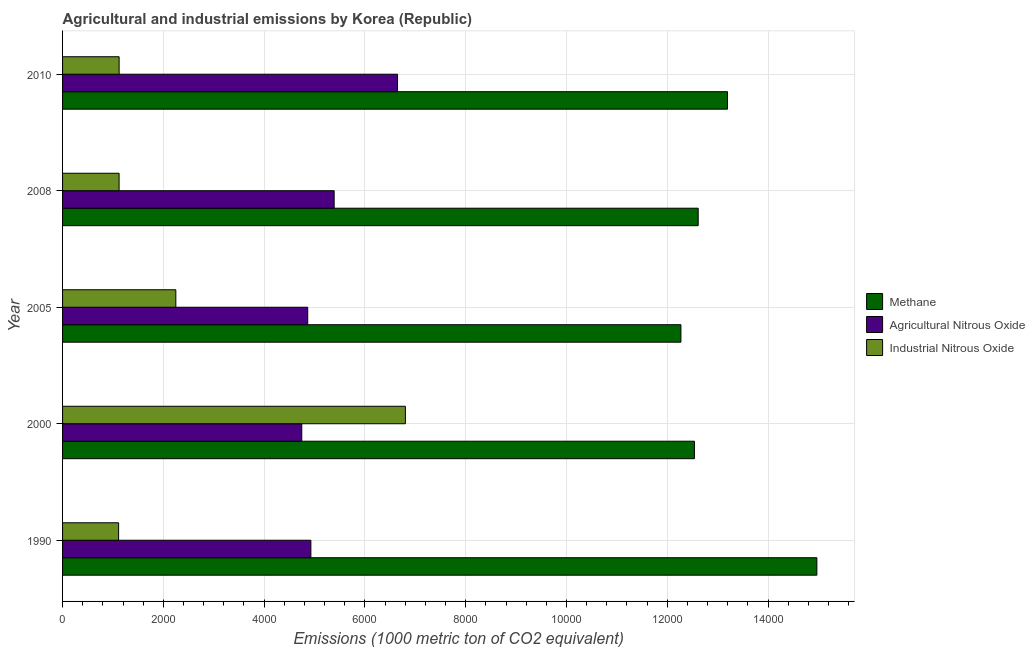How many groups of bars are there?
Provide a short and direct response. 5. Are the number of bars on each tick of the Y-axis equal?
Your answer should be compact. Yes. How many bars are there on the 4th tick from the top?
Offer a very short reply. 3. What is the label of the 5th group of bars from the top?
Offer a terse response. 1990. In how many cases, is the number of bars for a given year not equal to the number of legend labels?
Offer a terse response. 0. What is the amount of methane emissions in 2008?
Your response must be concise. 1.26e+04. Across all years, what is the maximum amount of industrial nitrous oxide emissions?
Keep it short and to the point. 6803. Across all years, what is the minimum amount of agricultural nitrous oxide emissions?
Your answer should be compact. 4746.8. What is the total amount of industrial nitrous oxide emissions in the graph?
Offer a very short reply. 1.24e+04. What is the difference between the amount of methane emissions in 2000 and that in 2008?
Make the answer very short. -74.3. What is the difference between the amount of methane emissions in 2000 and the amount of agricultural nitrous oxide emissions in 2010?
Provide a succinct answer. 5891.8. What is the average amount of agricultural nitrous oxide emissions per year?
Make the answer very short. 5315.22. In the year 1990, what is the difference between the amount of industrial nitrous oxide emissions and amount of agricultural nitrous oxide emissions?
Offer a terse response. -3815.1. In how many years, is the amount of industrial nitrous oxide emissions greater than 11200 metric ton?
Provide a short and direct response. 0. What is the ratio of the amount of agricultural nitrous oxide emissions in 1990 to that in 2005?
Your response must be concise. 1.01. Is the amount of methane emissions in 1990 less than that in 2010?
Your answer should be compact. No. Is the difference between the amount of industrial nitrous oxide emissions in 2000 and 2008 greater than the difference between the amount of agricultural nitrous oxide emissions in 2000 and 2008?
Your response must be concise. Yes. What is the difference between the highest and the second highest amount of methane emissions?
Your answer should be compact. 1774. What is the difference between the highest and the lowest amount of industrial nitrous oxide emissions?
Give a very brief answer. 5690.7. In how many years, is the amount of industrial nitrous oxide emissions greater than the average amount of industrial nitrous oxide emissions taken over all years?
Your response must be concise. 1. Is the sum of the amount of methane emissions in 1990 and 2008 greater than the maximum amount of agricultural nitrous oxide emissions across all years?
Ensure brevity in your answer.  Yes. What does the 1st bar from the top in 1990 represents?
Your response must be concise. Industrial Nitrous Oxide. What does the 2nd bar from the bottom in 2000 represents?
Your response must be concise. Agricultural Nitrous Oxide. How many bars are there?
Provide a succinct answer. 15. Are all the bars in the graph horizontal?
Make the answer very short. Yes. How many years are there in the graph?
Your answer should be compact. 5. Are the values on the major ticks of X-axis written in scientific E-notation?
Your answer should be compact. No. Does the graph contain any zero values?
Give a very brief answer. No. How many legend labels are there?
Offer a very short reply. 3. How are the legend labels stacked?
Provide a short and direct response. Vertical. What is the title of the graph?
Your response must be concise. Agricultural and industrial emissions by Korea (Republic). Does "Agricultural raw materials" appear as one of the legend labels in the graph?
Provide a short and direct response. No. What is the label or title of the X-axis?
Give a very brief answer. Emissions (1000 metric ton of CO2 equivalent). What is the Emissions (1000 metric ton of CO2 equivalent) of Methane in 1990?
Your response must be concise. 1.50e+04. What is the Emissions (1000 metric ton of CO2 equivalent) of Agricultural Nitrous Oxide in 1990?
Ensure brevity in your answer.  4927.4. What is the Emissions (1000 metric ton of CO2 equivalent) of Industrial Nitrous Oxide in 1990?
Ensure brevity in your answer.  1112.3. What is the Emissions (1000 metric ton of CO2 equivalent) in Methane in 2000?
Ensure brevity in your answer.  1.25e+04. What is the Emissions (1000 metric ton of CO2 equivalent) of Agricultural Nitrous Oxide in 2000?
Keep it short and to the point. 4746.8. What is the Emissions (1000 metric ton of CO2 equivalent) in Industrial Nitrous Oxide in 2000?
Make the answer very short. 6803. What is the Emissions (1000 metric ton of CO2 equivalent) of Methane in 2005?
Keep it short and to the point. 1.23e+04. What is the Emissions (1000 metric ton of CO2 equivalent) of Agricultural Nitrous Oxide in 2005?
Provide a succinct answer. 4865. What is the Emissions (1000 metric ton of CO2 equivalent) in Industrial Nitrous Oxide in 2005?
Your answer should be compact. 2247.5. What is the Emissions (1000 metric ton of CO2 equivalent) of Methane in 2008?
Provide a succinct answer. 1.26e+04. What is the Emissions (1000 metric ton of CO2 equivalent) in Agricultural Nitrous Oxide in 2008?
Provide a short and direct response. 5389.6. What is the Emissions (1000 metric ton of CO2 equivalent) in Industrial Nitrous Oxide in 2008?
Ensure brevity in your answer.  1121.9. What is the Emissions (1000 metric ton of CO2 equivalent) of Methane in 2010?
Make the answer very short. 1.32e+04. What is the Emissions (1000 metric ton of CO2 equivalent) in Agricultural Nitrous Oxide in 2010?
Offer a terse response. 6647.3. What is the Emissions (1000 metric ton of CO2 equivalent) in Industrial Nitrous Oxide in 2010?
Offer a terse response. 1122.5. Across all years, what is the maximum Emissions (1000 metric ton of CO2 equivalent) of Methane?
Your response must be concise. 1.50e+04. Across all years, what is the maximum Emissions (1000 metric ton of CO2 equivalent) of Agricultural Nitrous Oxide?
Keep it short and to the point. 6647.3. Across all years, what is the maximum Emissions (1000 metric ton of CO2 equivalent) of Industrial Nitrous Oxide?
Ensure brevity in your answer.  6803. Across all years, what is the minimum Emissions (1000 metric ton of CO2 equivalent) in Methane?
Your answer should be very brief. 1.23e+04. Across all years, what is the minimum Emissions (1000 metric ton of CO2 equivalent) in Agricultural Nitrous Oxide?
Provide a short and direct response. 4746.8. Across all years, what is the minimum Emissions (1000 metric ton of CO2 equivalent) of Industrial Nitrous Oxide?
Your answer should be compact. 1112.3. What is the total Emissions (1000 metric ton of CO2 equivalent) of Methane in the graph?
Give a very brief answer. 6.56e+04. What is the total Emissions (1000 metric ton of CO2 equivalent) of Agricultural Nitrous Oxide in the graph?
Your answer should be compact. 2.66e+04. What is the total Emissions (1000 metric ton of CO2 equivalent) of Industrial Nitrous Oxide in the graph?
Your response must be concise. 1.24e+04. What is the difference between the Emissions (1000 metric ton of CO2 equivalent) in Methane in 1990 and that in 2000?
Your answer should be compact. 2429.6. What is the difference between the Emissions (1000 metric ton of CO2 equivalent) of Agricultural Nitrous Oxide in 1990 and that in 2000?
Offer a terse response. 180.6. What is the difference between the Emissions (1000 metric ton of CO2 equivalent) of Industrial Nitrous Oxide in 1990 and that in 2000?
Keep it short and to the point. -5690.7. What is the difference between the Emissions (1000 metric ton of CO2 equivalent) of Methane in 1990 and that in 2005?
Your answer should be compact. 2697.7. What is the difference between the Emissions (1000 metric ton of CO2 equivalent) in Agricultural Nitrous Oxide in 1990 and that in 2005?
Make the answer very short. 62.4. What is the difference between the Emissions (1000 metric ton of CO2 equivalent) in Industrial Nitrous Oxide in 1990 and that in 2005?
Make the answer very short. -1135.2. What is the difference between the Emissions (1000 metric ton of CO2 equivalent) of Methane in 1990 and that in 2008?
Make the answer very short. 2355.3. What is the difference between the Emissions (1000 metric ton of CO2 equivalent) in Agricultural Nitrous Oxide in 1990 and that in 2008?
Provide a short and direct response. -462.2. What is the difference between the Emissions (1000 metric ton of CO2 equivalent) of Methane in 1990 and that in 2010?
Ensure brevity in your answer.  1774. What is the difference between the Emissions (1000 metric ton of CO2 equivalent) in Agricultural Nitrous Oxide in 1990 and that in 2010?
Provide a short and direct response. -1719.9. What is the difference between the Emissions (1000 metric ton of CO2 equivalent) in Industrial Nitrous Oxide in 1990 and that in 2010?
Your answer should be very brief. -10.2. What is the difference between the Emissions (1000 metric ton of CO2 equivalent) of Methane in 2000 and that in 2005?
Provide a succinct answer. 268.1. What is the difference between the Emissions (1000 metric ton of CO2 equivalent) of Agricultural Nitrous Oxide in 2000 and that in 2005?
Offer a terse response. -118.2. What is the difference between the Emissions (1000 metric ton of CO2 equivalent) in Industrial Nitrous Oxide in 2000 and that in 2005?
Offer a terse response. 4555.5. What is the difference between the Emissions (1000 metric ton of CO2 equivalent) of Methane in 2000 and that in 2008?
Keep it short and to the point. -74.3. What is the difference between the Emissions (1000 metric ton of CO2 equivalent) in Agricultural Nitrous Oxide in 2000 and that in 2008?
Make the answer very short. -642.8. What is the difference between the Emissions (1000 metric ton of CO2 equivalent) in Industrial Nitrous Oxide in 2000 and that in 2008?
Your answer should be compact. 5681.1. What is the difference between the Emissions (1000 metric ton of CO2 equivalent) of Methane in 2000 and that in 2010?
Offer a terse response. -655.6. What is the difference between the Emissions (1000 metric ton of CO2 equivalent) in Agricultural Nitrous Oxide in 2000 and that in 2010?
Make the answer very short. -1900.5. What is the difference between the Emissions (1000 metric ton of CO2 equivalent) of Industrial Nitrous Oxide in 2000 and that in 2010?
Your response must be concise. 5680.5. What is the difference between the Emissions (1000 metric ton of CO2 equivalent) in Methane in 2005 and that in 2008?
Offer a very short reply. -342.4. What is the difference between the Emissions (1000 metric ton of CO2 equivalent) of Agricultural Nitrous Oxide in 2005 and that in 2008?
Offer a very short reply. -524.6. What is the difference between the Emissions (1000 metric ton of CO2 equivalent) of Industrial Nitrous Oxide in 2005 and that in 2008?
Ensure brevity in your answer.  1125.6. What is the difference between the Emissions (1000 metric ton of CO2 equivalent) of Methane in 2005 and that in 2010?
Give a very brief answer. -923.7. What is the difference between the Emissions (1000 metric ton of CO2 equivalent) in Agricultural Nitrous Oxide in 2005 and that in 2010?
Your answer should be very brief. -1782.3. What is the difference between the Emissions (1000 metric ton of CO2 equivalent) in Industrial Nitrous Oxide in 2005 and that in 2010?
Your answer should be very brief. 1125. What is the difference between the Emissions (1000 metric ton of CO2 equivalent) of Methane in 2008 and that in 2010?
Provide a succinct answer. -581.3. What is the difference between the Emissions (1000 metric ton of CO2 equivalent) in Agricultural Nitrous Oxide in 2008 and that in 2010?
Your answer should be very brief. -1257.7. What is the difference between the Emissions (1000 metric ton of CO2 equivalent) in Methane in 1990 and the Emissions (1000 metric ton of CO2 equivalent) in Agricultural Nitrous Oxide in 2000?
Make the answer very short. 1.02e+04. What is the difference between the Emissions (1000 metric ton of CO2 equivalent) in Methane in 1990 and the Emissions (1000 metric ton of CO2 equivalent) in Industrial Nitrous Oxide in 2000?
Offer a very short reply. 8165.7. What is the difference between the Emissions (1000 metric ton of CO2 equivalent) of Agricultural Nitrous Oxide in 1990 and the Emissions (1000 metric ton of CO2 equivalent) of Industrial Nitrous Oxide in 2000?
Ensure brevity in your answer.  -1875.6. What is the difference between the Emissions (1000 metric ton of CO2 equivalent) of Methane in 1990 and the Emissions (1000 metric ton of CO2 equivalent) of Agricultural Nitrous Oxide in 2005?
Make the answer very short. 1.01e+04. What is the difference between the Emissions (1000 metric ton of CO2 equivalent) of Methane in 1990 and the Emissions (1000 metric ton of CO2 equivalent) of Industrial Nitrous Oxide in 2005?
Offer a terse response. 1.27e+04. What is the difference between the Emissions (1000 metric ton of CO2 equivalent) in Agricultural Nitrous Oxide in 1990 and the Emissions (1000 metric ton of CO2 equivalent) in Industrial Nitrous Oxide in 2005?
Offer a terse response. 2679.9. What is the difference between the Emissions (1000 metric ton of CO2 equivalent) in Methane in 1990 and the Emissions (1000 metric ton of CO2 equivalent) in Agricultural Nitrous Oxide in 2008?
Your response must be concise. 9579.1. What is the difference between the Emissions (1000 metric ton of CO2 equivalent) of Methane in 1990 and the Emissions (1000 metric ton of CO2 equivalent) of Industrial Nitrous Oxide in 2008?
Offer a very short reply. 1.38e+04. What is the difference between the Emissions (1000 metric ton of CO2 equivalent) of Agricultural Nitrous Oxide in 1990 and the Emissions (1000 metric ton of CO2 equivalent) of Industrial Nitrous Oxide in 2008?
Your answer should be very brief. 3805.5. What is the difference between the Emissions (1000 metric ton of CO2 equivalent) in Methane in 1990 and the Emissions (1000 metric ton of CO2 equivalent) in Agricultural Nitrous Oxide in 2010?
Your answer should be compact. 8321.4. What is the difference between the Emissions (1000 metric ton of CO2 equivalent) in Methane in 1990 and the Emissions (1000 metric ton of CO2 equivalent) in Industrial Nitrous Oxide in 2010?
Offer a terse response. 1.38e+04. What is the difference between the Emissions (1000 metric ton of CO2 equivalent) in Agricultural Nitrous Oxide in 1990 and the Emissions (1000 metric ton of CO2 equivalent) in Industrial Nitrous Oxide in 2010?
Ensure brevity in your answer.  3804.9. What is the difference between the Emissions (1000 metric ton of CO2 equivalent) in Methane in 2000 and the Emissions (1000 metric ton of CO2 equivalent) in Agricultural Nitrous Oxide in 2005?
Provide a succinct answer. 7674.1. What is the difference between the Emissions (1000 metric ton of CO2 equivalent) in Methane in 2000 and the Emissions (1000 metric ton of CO2 equivalent) in Industrial Nitrous Oxide in 2005?
Make the answer very short. 1.03e+04. What is the difference between the Emissions (1000 metric ton of CO2 equivalent) in Agricultural Nitrous Oxide in 2000 and the Emissions (1000 metric ton of CO2 equivalent) in Industrial Nitrous Oxide in 2005?
Make the answer very short. 2499.3. What is the difference between the Emissions (1000 metric ton of CO2 equivalent) of Methane in 2000 and the Emissions (1000 metric ton of CO2 equivalent) of Agricultural Nitrous Oxide in 2008?
Make the answer very short. 7149.5. What is the difference between the Emissions (1000 metric ton of CO2 equivalent) of Methane in 2000 and the Emissions (1000 metric ton of CO2 equivalent) of Industrial Nitrous Oxide in 2008?
Offer a terse response. 1.14e+04. What is the difference between the Emissions (1000 metric ton of CO2 equivalent) in Agricultural Nitrous Oxide in 2000 and the Emissions (1000 metric ton of CO2 equivalent) in Industrial Nitrous Oxide in 2008?
Keep it short and to the point. 3624.9. What is the difference between the Emissions (1000 metric ton of CO2 equivalent) in Methane in 2000 and the Emissions (1000 metric ton of CO2 equivalent) in Agricultural Nitrous Oxide in 2010?
Your response must be concise. 5891.8. What is the difference between the Emissions (1000 metric ton of CO2 equivalent) in Methane in 2000 and the Emissions (1000 metric ton of CO2 equivalent) in Industrial Nitrous Oxide in 2010?
Your answer should be very brief. 1.14e+04. What is the difference between the Emissions (1000 metric ton of CO2 equivalent) of Agricultural Nitrous Oxide in 2000 and the Emissions (1000 metric ton of CO2 equivalent) of Industrial Nitrous Oxide in 2010?
Offer a terse response. 3624.3. What is the difference between the Emissions (1000 metric ton of CO2 equivalent) of Methane in 2005 and the Emissions (1000 metric ton of CO2 equivalent) of Agricultural Nitrous Oxide in 2008?
Give a very brief answer. 6881.4. What is the difference between the Emissions (1000 metric ton of CO2 equivalent) in Methane in 2005 and the Emissions (1000 metric ton of CO2 equivalent) in Industrial Nitrous Oxide in 2008?
Keep it short and to the point. 1.11e+04. What is the difference between the Emissions (1000 metric ton of CO2 equivalent) of Agricultural Nitrous Oxide in 2005 and the Emissions (1000 metric ton of CO2 equivalent) of Industrial Nitrous Oxide in 2008?
Ensure brevity in your answer.  3743.1. What is the difference between the Emissions (1000 metric ton of CO2 equivalent) in Methane in 2005 and the Emissions (1000 metric ton of CO2 equivalent) in Agricultural Nitrous Oxide in 2010?
Keep it short and to the point. 5623.7. What is the difference between the Emissions (1000 metric ton of CO2 equivalent) in Methane in 2005 and the Emissions (1000 metric ton of CO2 equivalent) in Industrial Nitrous Oxide in 2010?
Offer a terse response. 1.11e+04. What is the difference between the Emissions (1000 metric ton of CO2 equivalent) in Agricultural Nitrous Oxide in 2005 and the Emissions (1000 metric ton of CO2 equivalent) in Industrial Nitrous Oxide in 2010?
Offer a very short reply. 3742.5. What is the difference between the Emissions (1000 metric ton of CO2 equivalent) of Methane in 2008 and the Emissions (1000 metric ton of CO2 equivalent) of Agricultural Nitrous Oxide in 2010?
Your answer should be compact. 5966.1. What is the difference between the Emissions (1000 metric ton of CO2 equivalent) in Methane in 2008 and the Emissions (1000 metric ton of CO2 equivalent) in Industrial Nitrous Oxide in 2010?
Your answer should be very brief. 1.15e+04. What is the difference between the Emissions (1000 metric ton of CO2 equivalent) of Agricultural Nitrous Oxide in 2008 and the Emissions (1000 metric ton of CO2 equivalent) of Industrial Nitrous Oxide in 2010?
Ensure brevity in your answer.  4267.1. What is the average Emissions (1000 metric ton of CO2 equivalent) in Methane per year?
Your answer should be very brief. 1.31e+04. What is the average Emissions (1000 metric ton of CO2 equivalent) of Agricultural Nitrous Oxide per year?
Provide a short and direct response. 5315.22. What is the average Emissions (1000 metric ton of CO2 equivalent) in Industrial Nitrous Oxide per year?
Your answer should be very brief. 2481.44. In the year 1990, what is the difference between the Emissions (1000 metric ton of CO2 equivalent) of Methane and Emissions (1000 metric ton of CO2 equivalent) of Agricultural Nitrous Oxide?
Your answer should be compact. 1.00e+04. In the year 1990, what is the difference between the Emissions (1000 metric ton of CO2 equivalent) of Methane and Emissions (1000 metric ton of CO2 equivalent) of Industrial Nitrous Oxide?
Your answer should be compact. 1.39e+04. In the year 1990, what is the difference between the Emissions (1000 metric ton of CO2 equivalent) of Agricultural Nitrous Oxide and Emissions (1000 metric ton of CO2 equivalent) of Industrial Nitrous Oxide?
Provide a succinct answer. 3815.1. In the year 2000, what is the difference between the Emissions (1000 metric ton of CO2 equivalent) in Methane and Emissions (1000 metric ton of CO2 equivalent) in Agricultural Nitrous Oxide?
Ensure brevity in your answer.  7792.3. In the year 2000, what is the difference between the Emissions (1000 metric ton of CO2 equivalent) in Methane and Emissions (1000 metric ton of CO2 equivalent) in Industrial Nitrous Oxide?
Ensure brevity in your answer.  5736.1. In the year 2000, what is the difference between the Emissions (1000 metric ton of CO2 equivalent) of Agricultural Nitrous Oxide and Emissions (1000 metric ton of CO2 equivalent) of Industrial Nitrous Oxide?
Ensure brevity in your answer.  -2056.2. In the year 2005, what is the difference between the Emissions (1000 metric ton of CO2 equivalent) of Methane and Emissions (1000 metric ton of CO2 equivalent) of Agricultural Nitrous Oxide?
Offer a very short reply. 7406. In the year 2005, what is the difference between the Emissions (1000 metric ton of CO2 equivalent) in Methane and Emissions (1000 metric ton of CO2 equivalent) in Industrial Nitrous Oxide?
Provide a succinct answer. 1.00e+04. In the year 2005, what is the difference between the Emissions (1000 metric ton of CO2 equivalent) of Agricultural Nitrous Oxide and Emissions (1000 metric ton of CO2 equivalent) of Industrial Nitrous Oxide?
Keep it short and to the point. 2617.5. In the year 2008, what is the difference between the Emissions (1000 metric ton of CO2 equivalent) of Methane and Emissions (1000 metric ton of CO2 equivalent) of Agricultural Nitrous Oxide?
Your answer should be very brief. 7223.8. In the year 2008, what is the difference between the Emissions (1000 metric ton of CO2 equivalent) of Methane and Emissions (1000 metric ton of CO2 equivalent) of Industrial Nitrous Oxide?
Provide a succinct answer. 1.15e+04. In the year 2008, what is the difference between the Emissions (1000 metric ton of CO2 equivalent) in Agricultural Nitrous Oxide and Emissions (1000 metric ton of CO2 equivalent) in Industrial Nitrous Oxide?
Give a very brief answer. 4267.7. In the year 2010, what is the difference between the Emissions (1000 metric ton of CO2 equivalent) of Methane and Emissions (1000 metric ton of CO2 equivalent) of Agricultural Nitrous Oxide?
Ensure brevity in your answer.  6547.4. In the year 2010, what is the difference between the Emissions (1000 metric ton of CO2 equivalent) in Methane and Emissions (1000 metric ton of CO2 equivalent) in Industrial Nitrous Oxide?
Ensure brevity in your answer.  1.21e+04. In the year 2010, what is the difference between the Emissions (1000 metric ton of CO2 equivalent) in Agricultural Nitrous Oxide and Emissions (1000 metric ton of CO2 equivalent) in Industrial Nitrous Oxide?
Your answer should be compact. 5524.8. What is the ratio of the Emissions (1000 metric ton of CO2 equivalent) in Methane in 1990 to that in 2000?
Your answer should be compact. 1.19. What is the ratio of the Emissions (1000 metric ton of CO2 equivalent) in Agricultural Nitrous Oxide in 1990 to that in 2000?
Provide a short and direct response. 1.04. What is the ratio of the Emissions (1000 metric ton of CO2 equivalent) in Industrial Nitrous Oxide in 1990 to that in 2000?
Offer a terse response. 0.16. What is the ratio of the Emissions (1000 metric ton of CO2 equivalent) of Methane in 1990 to that in 2005?
Keep it short and to the point. 1.22. What is the ratio of the Emissions (1000 metric ton of CO2 equivalent) in Agricultural Nitrous Oxide in 1990 to that in 2005?
Give a very brief answer. 1.01. What is the ratio of the Emissions (1000 metric ton of CO2 equivalent) in Industrial Nitrous Oxide in 1990 to that in 2005?
Provide a short and direct response. 0.49. What is the ratio of the Emissions (1000 metric ton of CO2 equivalent) of Methane in 1990 to that in 2008?
Offer a very short reply. 1.19. What is the ratio of the Emissions (1000 metric ton of CO2 equivalent) in Agricultural Nitrous Oxide in 1990 to that in 2008?
Your answer should be compact. 0.91. What is the ratio of the Emissions (1000 metric ton of CO2 equivalent) in Methane in 1990 to that in 2010?
Ensure brevity in your answer.  1.13. What is the ratio of the Emissions (1000 metric ton of CO2 equivalent) of Agricultural Nitrous Oxide in 1990 to that in 2010?
Your answer should be compact. 0.74. What is the ratio of the Emissions (1000 metric ton of CO2 equivalent) of Industrial Nitrous Oxide in 1990 to that in 2010?
Give a very brief answer. 0.99. What is the ratio of the Emissions (1000 metric ton of CO2 equivalent) in Methane in 2000 to that in 2005?
Provide a succinct answer. 1.02. What is the ratio of the Emissions (1000 metric ton of CO2 equivalent) of Agricultural Nitrous Oxide in 2000 to that in 2005?
Offer a terse response. 0.98. What is the ratio of the Emissions (1000 metric ton of CO2 equivalent) in Industrial Nitrous Oxide in 2000 to that in 2005?
Keep it short and to the point. 3.03. What is the ratio of the Emissions (1000 metric ton of CO2 equivalent) of Agricultural Nitrous Oxide in 2000 to that in 2008?
Your answer should be very brief. 0.88. What is the ratio of the Emissions (1000 metric ton of CO2 equivalent) of Industrial Nitrous Oxide in 2000 to that in 2008?
Offer a terse response. 6.06. What is the ratio of the Emissions (1000 metric ton of CO2 equivalent) in Methane in 2000 to that in 2010?
Provide a succinct answer. 0.95. What is the ratio of the Emissions (1000 metric ton of CO2 equivalent) in Agricultural Nitrous Oxide in 2000 to that in 2010?
Ensure brevity in your answer.  0.71. What is the ratio of the Emissions (1000 metric ton of CO2 equivalent) in Industrial Nitrous Oxide in 2000 to that in 2010?
Ensure brevity in your answer.  6.06. What is the ratio of the Emissions (1000 metric ton of CO2 equivalent) in Methane in 2005 to that in 2008?
Provide a succinct answer. 0.97. What is the ratio of the Emissions (1000 metric ton of CO2 equivalent) in Agricultural Nitrous Oxide in 2005 to that in 2008?
Your answer should be very brief. 0.9. What is the ratio of the Emissions (1000 metric ton of CO2 equivalent) of Industrial Nitrous Oxide in 2005 to that in 2008?
Your answer should be very brief. 2. What is the ratio of the Emissions (1000 metric ton of CO2 equivalent) in Agricultural Nitrous Oxide in 2005 to that in 2010?
Make the answer very short. 0.73. What is the ratio of the Emissions (1000 metric ton of CO2 equivalent) of Industrial Nitrous Oxide in 2005 to that in 2010?
Offer a terse response. 2. What is the ratio of the Emissions (1000 metric ton of CO2 equivalent) of Methane in 2008 to that in 2010?
Provide a succinct answer. 0.96. What is the ratio of the Emissions (1000 metric ton of CO2 equivalent) of Agricultural Nitrous Oxide in 2008 to that in 2010?
Provide a succinct answer. 0.81. What is the difference between the highest and the second highest Emissions (1000 metric ton of CO2 equivalent) in Methane?
Ensure brevity in your answer.  1774. What is the difference between the highest and the second highest Emissions (1000 metric ton of CO2 equivalent) in Agricultural Nitrous Oxide?
Provide a short and direct response. 1257.7. What is the difference between the highest and the second highest Emissions (1000 metric ton of CO2 equivalent) in Industrial Nitrous Oxide?
Your answer should be compact. 4555.5. What is the difference between the highest and the lowest Emissions (1000 metric ton of CO2 equivalent) in Methane?
Your answer should be very brief. 2697.7. What is the difference between the highest and the lowest Emissions (1000 metric ton of CO2 equivalent) of Agricultural Nitrous Oxide?
Your response must be concise. 1900.5. What is the difference between the highest and the lowest Emissions (1000 metric ton of CO2 equivalent) in Industrial Nitrous Oxide?
Make the answer very short. 5690.7. 